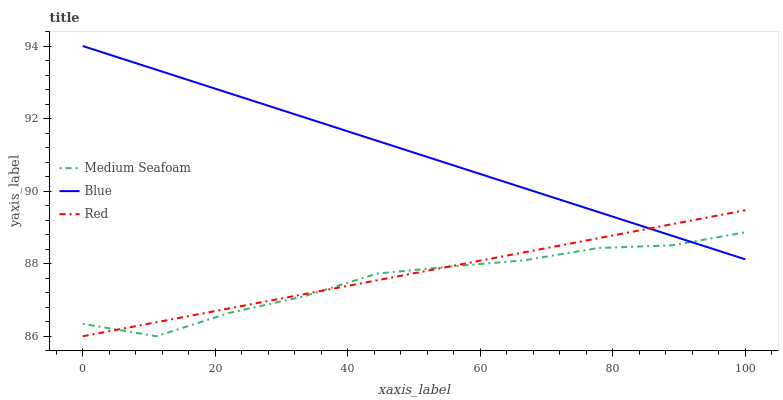Does Medium Seafoam have the minimum area under the curve?
Answer yes or no. Yes. Does Blue have the maximum area under the curve?
Answer yes or no. Yes. Does Red have the minimum area under the curve?
Answer yes or no. No. Does Red have the maximum area under the curve?
Answer yes or no. No. Is Red the smoothest?
Answer yes or no. Yes. Is Medium Seafoam the roughest?
Answer yes or no. Yes. Is Medium Seafoam the smoothest?
Answer yes or no. No. Is Red the roughest?
Answer yes or no. No. Does Blue have the highest value?
Answer yes or no. Yes. Does Red have the highest value?
Answer yes or no. No. Does Blue intersect Medium Seafoam?
Answer yes or no. Yes. Is Blue less than Medium Seafoam?
Answer yes or no. No. Is Blue greater than Medium Seafoam?
Answer yes or no. No. 